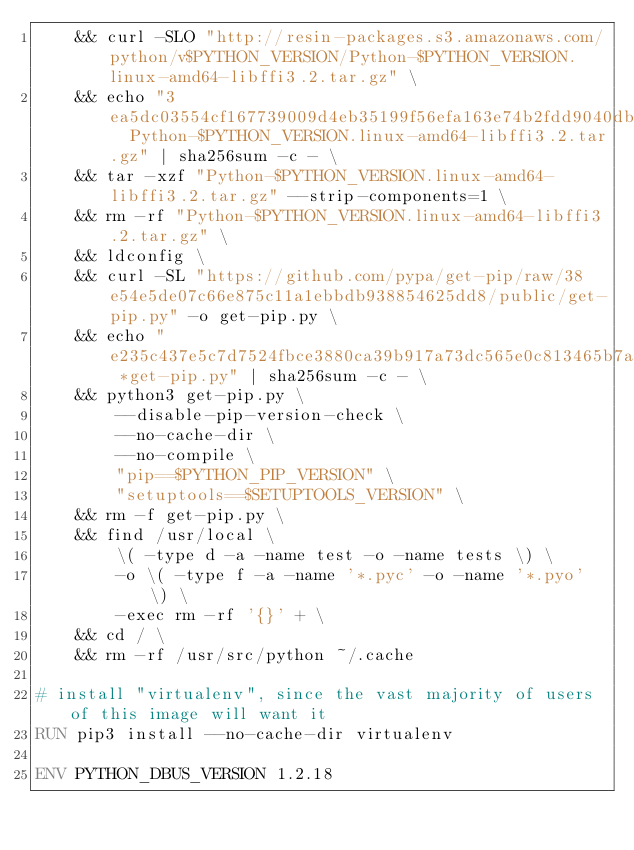Convert code to text. <code><loc_0><loc_0><loc_500><loc_500><_Dockerfile_>    && curl -SLO "http://resin-packages.s3.amazonaws.com/python/v$PYTHON_VERSION/Python-$PYTHON_VERSION.linux-amd64-libffi3.2.tar.gz" \
    && echo "3ea5dc03554cf167739009d4eb35199f56efa163e74b2fdd9040db697e72cbb7  Python-$PYTHON_VERSION.linux-amd64-libffi3.2.tar.gz" | sha256sum -c - \
    && tar -xzf "Python-$PYTHON_VERSION.linux-amd64-libffi3.2.tar.gz" --strip-components=1 \
    && rm -rf "Python-$PYTHON_VERSION.linux-amd64-libffi3.2.tar.gz" \
    && ldconfig \
    && curl -SL "https://github.com/pypa/get-pip/raw/38e54e5de07c66e875c11a1ebbdb938854625dd8/public/get-pip.py" -o get-pip.py \
    && echo "e235c437e5c7d7524fbce3880ca39b917a73dc565e0c813465b7a7a329bb279a *get-pip.py" | sha256sum -c - \
    && python3 get-pip.py \
        --disable-pip-version-check \
        --no-cache-dir \
        --no-compile \
        "pip==$PYTHON_PIP_VERSION" \
        "setuptools==$SETUPTOOLS_VERSION" \
    && rm -f get-pip.py \
    && find /usr/local \
        \( -type d -a -name test -o -name tests \) \
        -o \( -type f -a -name '*.pyc' -o -name '*.pyo' \) \
        -exec rm -rf '{}' + \
    && cd / \
    && rm -rf /usr/src/python ~/.cache

# install "virtualenv", since the vast majority of users of this image will want it
RUN pip3 install --no-cache-dir virtualenv

ENV PYTHON_DBUS_VERSION 1.2.18
</code> 